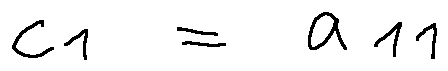Convert formula to latex. <formula><loc_0><loc_0><loc_500><loc_500>c _ { 1 } = a _ { 1 1 }</formula> 